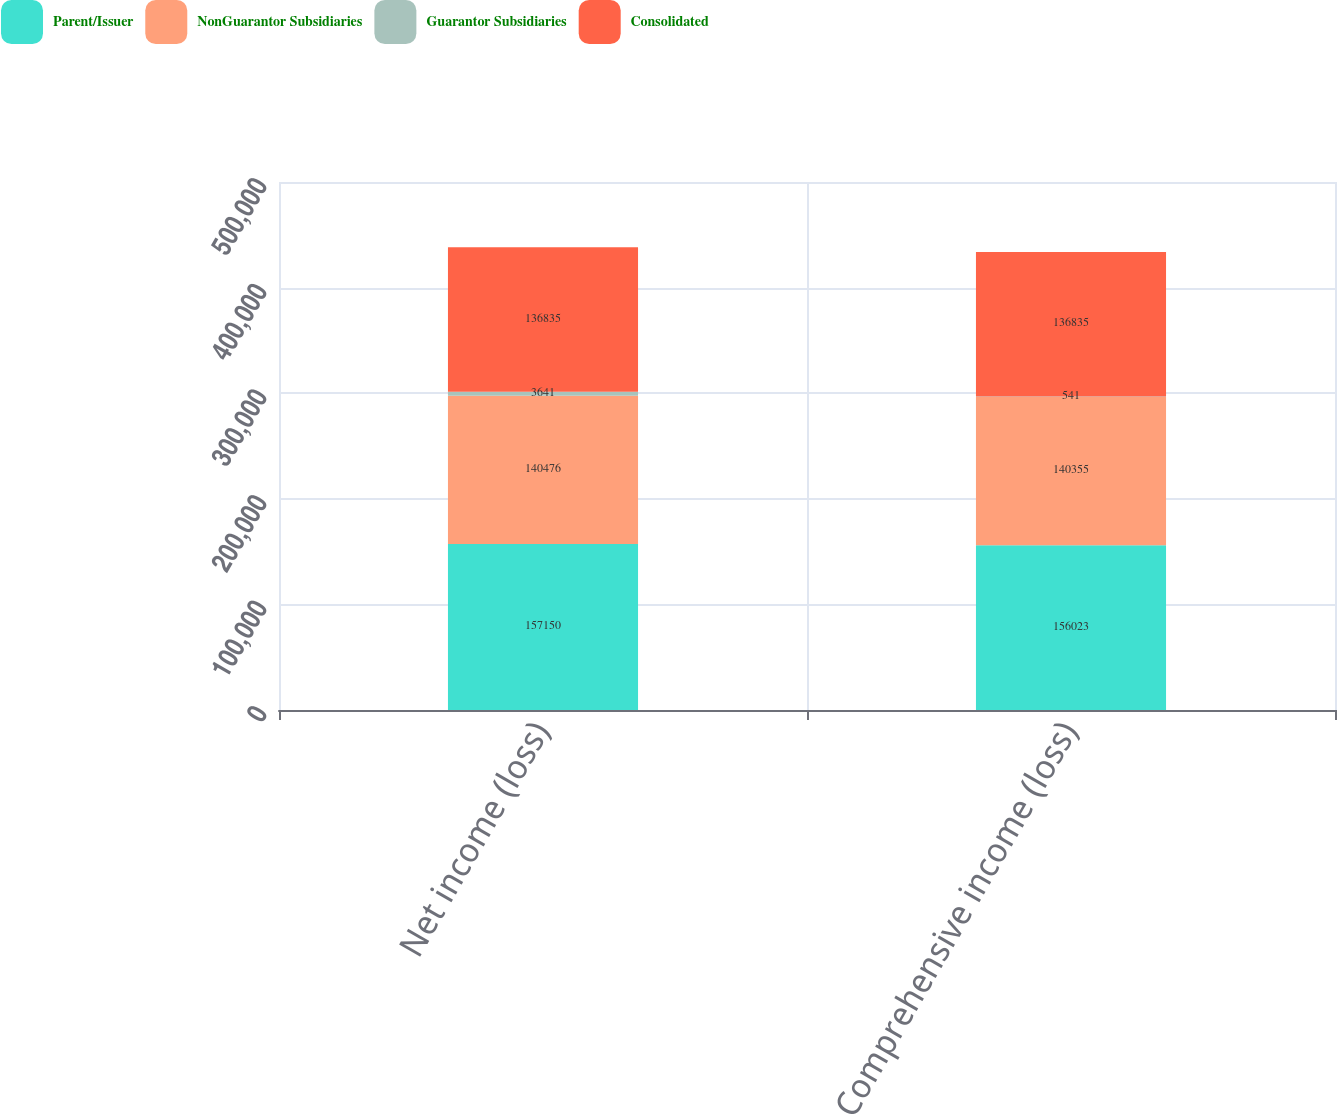<chart> <loc_0><loc_0><loc_500><loc_500><stacked_bar_chart><ecel><fcel>Net income (loss)<fcel>Comprehensive income (loss)<nl><fcel>Parent/Issuer<fcel>157150<fcel>156023<nl><fcel>NonGuarantor Subsidiaries<fcel>140476<fcel>140355<nl><fcel>Guarantor Subsidiaries<fcel>3641<fcel>541<nl><fcel>Consolidated<fcel>136835<fcel>136835<nl></chart> 